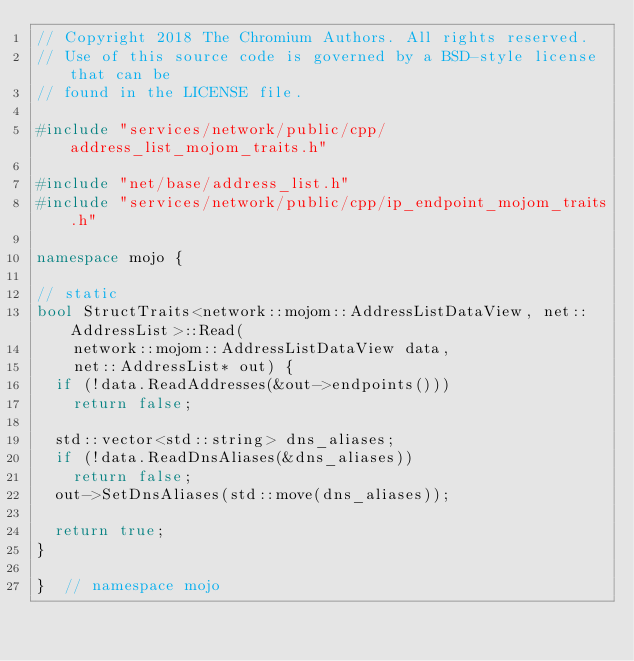Convert code to text. <code><loc_0><loc_0><loc_500><loc_500><_C++_>// Copyright 2018 The Chromium Authors. All rights reserved.
// Use of this source code is governed by a BSD-style license that can be
// found in the LICENSE file.

#include "services/network/public/cpp/address_list_mojom_traits.h"

#include "net/base/address_list.h"
#include "services/network/public/cpp/ip_endpoint_mojom_traits.h"

namespace mojo {

// static
bool StructTraits<network::mojom::AddressListDataView, net::AddressList>::Read(
    network::mojom::AddressListDataView data,
    net::AddressList* out) {
  if (!data.ReadAddresses(&out->endpoints()))
    return false;

  std::vector<std::string> dns_aliases;
  if (!data.ReadDnsAliases(&dns_aliases))
    return false;
  out->SetDnsAliases(std::move(dns_aliases));

  return true;
}

}  // namespace mojo
</code> 